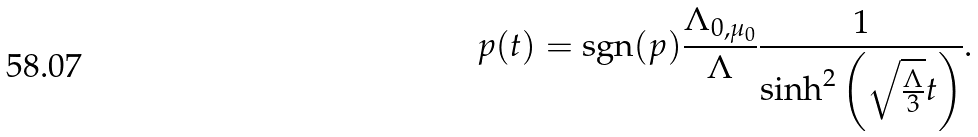<formula> <loc_0><loc_0><loc_500><loc_500>p ( t ) = \text {sgn} ( p ) \frac { \Lambda _ { 0 , \mu _ { 0 } } } { \Lambda } \frac { 1 } { \sinh ^ { 2 } { \left ( \sqrt { \frac { \Lambda } { 3 } } t \right ) } } .</formula> 